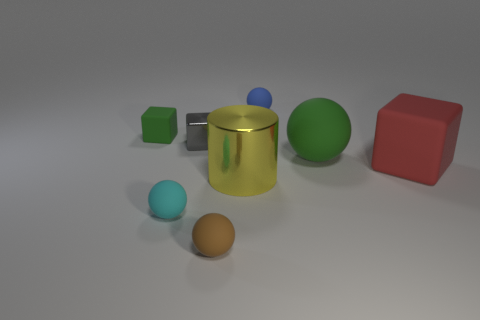Add 1 big blue shiny spheres. How many objects exist? 9 Subtract all cylinders. How many objects are left? 7 Add 8 big cylinders. How many big cylinders are left? 9 Add 3 big yellow things. How many big yellow things exist? 4 Subtract 0 brown cylinders. How many objects are left? 8 Subtract all green rubber things. Subtract all cyan balls. How many objects are left? 5 